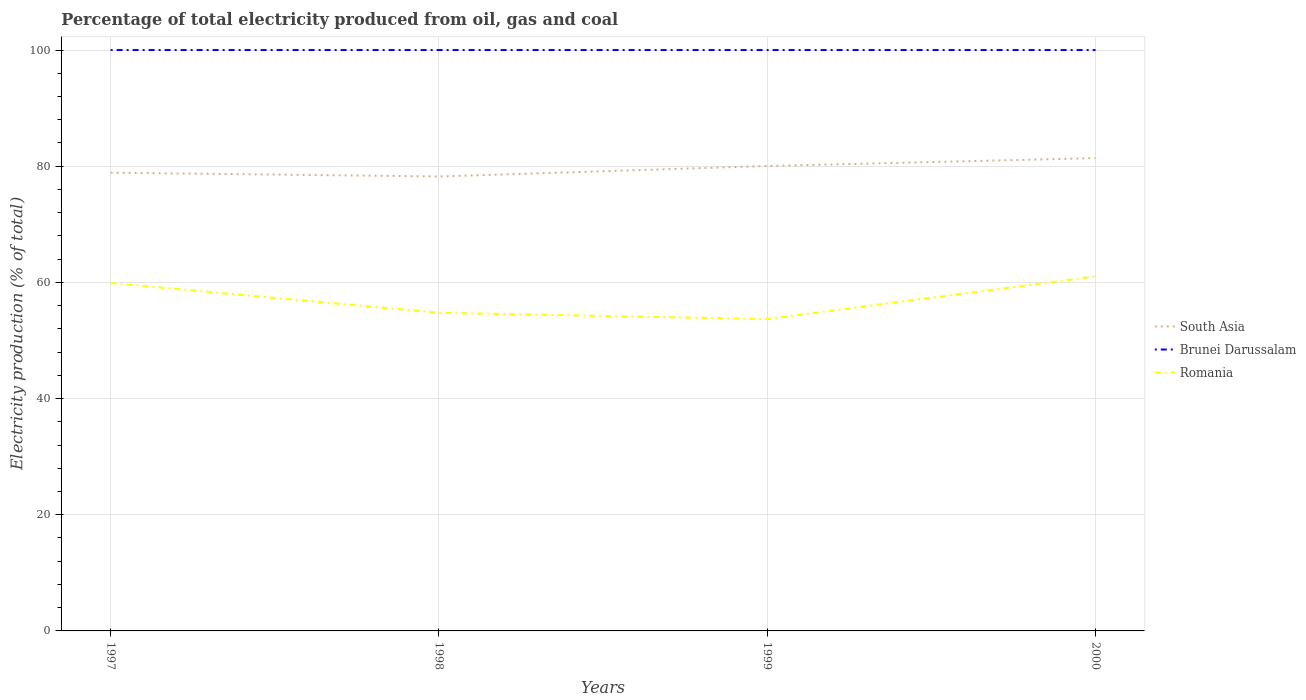Does the line corresponding to Romania intersect with the line corresponding to Brunei Darussalam?
Your answer should be very brief. No. Is the number of lines equal to the number of legend labels?
Provide a succinct answer. Yes. What is the total electricity production in in Brunei Darussalam in the graph?
Give a very brief answer. 0. What is the difference between the highest and the second highest electricity production in in Romania?
Offer a very short reply. 7.36. What is the difference between the highest and the lowest electricity production in in South Asia?
Provide a succinct answer. 2. Is the electricity production in in Romania strictly greater than the electricity production in in Brunei Darussalam over the years?
Keep it short and to the point. Yes. What is the difference between two consecutive major ticks on the Y-axis?
Provide a succinct answer. 20. Does the graph contain any zero values?
Keep it short and to the point. No. How many legend labels are there?
Ensure brevity in your answer.  3. What is the title of the graph?
Make the answer very short. Percentage of total electricity produced from oil, gas and coal. Does "American Samoa" appear as one of the legend labels in the graph?
Keep it short and to the point. No. What is the label or title of the Y-axis?
Offer a very short reply. Electricity production (% of total). What is the Electricity production (% of total) of South Asia in 1997?
Your answer should be very brief. 78.88. What is the Electricity production (% of total) in Romania in 1997?
Offer a very short reply. 59.89. What is the Electricity production (% of total) in South Asia in 1998?
Ensure brevity in your answer.  78.23. What is the Electricity production (% of total) of Romania in 1998?
Ensure brevity in your answer.  54.77. What is the Electricity production (% of total) in South Asia in 1999?
Provide a short and direct response. 80.04. What is the Electricity production (% of total) in Brunei Darussalam in 1999?
Give a very brief answer. 100. What is the Electricity production (% of total) in Romania in 1999?
Offer a terse response. 53.68. What is the Electricity production (% of total) of South Asia in 2000?
Ensure brevity in your answer.  81.39. What is the Electricity production (% of total) in Romania in 2000?
Provide a short and direct response. 61.04. Across all years, what is the maximum Electricity production (% of total) of South Asia?
Provide a short and direct response. 81.39. Across all years, what is the maximum Electricity production (% of total) in Romania?
Your response must be concise. 61.04. Across all years, what is the minimum Electricity production (% of total) of South Asia?
Ensure brevity in your answer.  78.23. Across all years, what is the minimum Electricity production (% of total) in Romania?
Keep it short and to the point. 53.68. What is the total Electricity production (% of total) of South Asia in the graph?
Your answer should be compact. 318.55. What is the total Electricity production (% of total) of Brunei Darussalam in the graph?
Provide a short and direct response. 400. What is the total Electricity production (% of total) in Romania in the graph?
Offer a terse response. 229.38. What is the difference between the Electricity production (% of total) of South Asia in 1997 and that in 1998?
Ensure brevity in your answer.  0.65. What is the difference between the Electricity production (% of total) of Brunei Darussalam in 1997 and that in 1998?
Give a very brief answer. 0. What is the difference between the Electricity production (% of total) of Romania in 1997 and that in 1998?
Provide a short and direct response. 5.12. What is the difference between the Electricity production (% of total) in South Asia in 1997 and that in 1999?
Your answer should be very brief. -1.15. What is the difference between the Electricity production (% of total) of Romania in 1997 and that in 1999?
Your answer should be very brief. 6.21. What is the difference between the Electricity production (% of total) in South Asia in 1997 and that in 2000?
Keep it short and to the point. -2.51. What is the difference between the Electricity production (% of total) in Romania in 1997 and that in 2000?
Keep it short and to the point. -1.15. What is the difference between the Electricity production (% of total) in South Asia in 1998 and that in 1999?
Offer a very short reply. -1.81. What is the difference between the Electricity production (% of total) in Romania in 1998 and that in 1999?
Provide a short and direct response. 1.09. What is the difference between the Electricity production (% of total) in South Asia in 1998 and that in 2000?
Your answer should be very brief. -3.16. What is the difference between the Electricity production (% of total) of Brunei Darussalam in 1998 and that in 2000?
Your answer should be very brief. 0. What is the difference between the Electricity production (% of total) in Romania in 1998 and that in 2000?
Keep it short and to the point. -6.27. What is the difference between the Electricity production (% of total) of South Asia in 1999 and that in 2000?
Give a very brief answer. -1.36. What is the difference between the Electricity production (% of total) in Brunei Darussalam in 1999 and that in 2000?
Provide a short and direct response. 0. What is the difference between the Electricity production (% of total) in Romania in 1999 and that in 2000?
Offer a terse response. -7.36. What is the difference between the Electricity production (% of total) of South Asia in 1997 and the Electricity production (% of total) of Brunei Darussalam in 1998?
Provide a succinct answer. -21.12. What is the difference between the Electricity production (% of total) in South Asia in 1997 and the Electricity production (% of total) in Romania in 1998?
Your answer should be compact. 24.11. What is the difference between the Electricity production (% of total) in Brunei Darussalam in 1997 and the Electricity production (% of total) in Romania in 1998?
Keep it short and to the point. 45.23. What is the difference between the Electricity production (% of total) of South Asia in 1997 and the Electricity production (% of total) of Brunei Darussalam in 1999?
Keep it short and to the point. -21.12. What is the difference between the Electricity production (% of total) of South Asia in 1997 and the Electricity production (% of total) of Romania in 1999?
Your answer should be compact. 25.2. What is the difference between the Electricity production (% of total) in Brunei Darussalam in 1997 and the Electricity production (% of total) in Romania in 1999?
Give a very brief answer. 46.32. What is the difference between the Electricity production (% of total) of South Asia in 1997 and the Electricity production (% of total) of Brunei Darussalam in 2000?
Offer a terse response. -21.12. What is the difference between the Electricity production (% of total) of South Asia in 1997 and the Electricity production (% of total) of Romania in 2000?
Keep it short and to the point. 17.84. What is the difference between the Electricity production (% of total) of Brunei Darussalam in 1997 and the Electricity production (% of total) of Romania in 2000?
Offer a very short reply. 38.96. What is the difference between the Electricity production (% of total) of South Asia in 1998 and the Electricity production (% of total) of Brunei Darussalam in 1999?
Give a very brief answer. -21.77. What is the difference between the Electricity production (% of total) in South Asia in 1998 and the Electricity production (% of total) in Romania in 1999?
Provide a succinct answer. 24.55. What is the difference between the Electricity production (% of total) in Brunei Darussalam in 1998 and the Electricity production (% of total) in Romania in 1999?
Provide a short and direct response. 46.32. What is the difference between the Electricity production (% of total) in South Asia in 1998 and the Electricity production (% of total) in Brunei Darussalam in 2000?
Make the answer very short. -21.77. What is the difference between the Electricity production (% of total) in South Asia in 1998 and the Electricity production (% of total) in Romania in 2000?
Provide a short and direct response. 17.19. What is the difference between the Electricity production (% of total) in Brunei Darussalam in 1998 and the Electricity production (% of total) in Romania in 2000?
Provide a short and direct response. 38.96. What is the difference between the Electricity production (% of total) in South Asia in 1999 and the Electricity production (% of total) in Brunei Darussalam in 2000?
Your answer should be very brief. -19.96. What is the difference between the Electricity production (% of total) of South Asia in 1999 and the Electricity production (% of total) of Romania in 2000?
Your answer should be compact. 19. What is the difference between the Electricity production (% of total) in Brunei Darussalam in 1999 and the Electricity production (% of total) in Romania in 2000?
Your response must be concise. 38.96. What is the average Electricity production (% of total) in South Asia per year?
Your answer should be compact. 79.64. What is the average Electricity production (% of total) of Brunei Darussalam per year?
Your answer should be compact. 100. What is the average Electricity production (% of total) of Romania per year?
Offer a terse response. 57.35. In the year 1997, what is the difference between the Electricity production (% of total) of South Asia and Electricity production (% of total) of Brunei Darussalam?
Offer a very short reply. -21.12. In the year 1997, what is the difference between the Electricity production (% of total) in South Asia and Electricity production (% of total) in Romania?
Keep it short and to the point. 18.99. In the year 1997, what is the difference between the Electricity production (% of total) of Brunei Darussalam and Electricity production (% of total) of Romania?
Offer a very short reply. 40.11. In the year 1998, what is the difference between the Electricity production (% of total) of South Asia and Electricity production (% of total) of Brunei Darussalam?
Keep it short and to the point. -21.77. In the year 1998, what is the difference between the Electricity production (% of total) in South Asia and Electricity production (% of total) in Romania?
Provide a short and direct response. 23.46. In the year 1998, what is the difference between the Electricity production (% of total) in Brunei Darussalam and Electricity production (% of total) in Romania?
Your answer should be compact. 45.23. In the year 1999, what is the difference between the Electricity production (% of total) in South Asia and Electricity production (% of total) in Brunei Darussalam?
Your answer should be compact. -19.96. In the year 1999, what is the difference between the Electricity production (% of total) of South Asia and Electricity production (% of total) of Romania?
Your answer should be very brief. 26.36. In the year 1999, what is the difference between the Electricity production (% of total) in Brunei Darussalam and Electricity production (% of total) in Romania?
Make the answer very short. 46.32. In the year 2000, what is the difference between the Electricity production (% of total) of South Asia and Electricity production (% of total) of Brunei Darussalam?
Make the answer very short. -18.61. In the year 2000, what is the difference between the Electricity production (% of total) of South Asia and Electricity production (% of total) of Romania?
Provide a short and direct response. 20.35. In the year 2000, what is the difference between the Electricity production (% of total) of Brunei Darussalam and Electricity production (% of total) of Romania?
Offer a terse response. 38.96. What is the ratio of the Electricity production (% of total) of South Asia in 1997 to that in 1998?
Your answer should be very brief. 1.01. What is the ratio of the Electricity production (% of total) of Romania in 1997 to that in 1998?
Make the answer very short. 1.09. What is the ratio of the Electricity production (% of total) in South Asia in 1997 to that in 1999?
Your answer should be very brief. 0.99. What is the ratio of the Electricity production (% of total) of Romania in 1997 to that in 1999?
Offer a very short reply. 1.12. What is the ratio of the Electricity production (% of total) in South Asia in 1997 to that in 2000?
Make the answer very short. 0.97. What is the ratio of the Electricity production (% of total) of Romania in 1997 to that in 2000?
Offer a terse response. 0.98. What is the ratio of the Electricity production (% of total) of South Asia in 1998 to that in 1999?
Provide a succinct answer. 0.98. What is the ratio of the Electricity production (% of total) in Brunei Darussalam in 1998 to that in 1999?
Provide a short and direct response. 1. What is the ratio of the Electricity production (% of total) in Romania in 1998 to that in 1999?
Offer a terse response. 1.02. What is the ratio of the Electricity production (% of total) in South Asia in 1998 to that in 2000?
Keep it short and to the point. 0.96. What is the ratio of the Electricity production (% of total) of Romania in 1998 to that in 2000?
Offer a very short reply. 0.9. What is the ratio of the Electricity production (% of total) in South Asia in 1999 to that in 2000?
Give a very brief answer. 0.98. What is the ratio of the Electricity production (% of total) of Brunei Darussalam in 1999 to that in 2000?
Provide a short and direct response. 1. What is the ratio of the Electricity production (% of total) in Romania in 1999 to that in 2000?
Provide a short and direct response. 0.88. What is the difference between the highest and the second highest Electricity production (% of total) in South Asia?
Give a very brief answer. 1.36. What is the difference between the highest and the second highest Electricity production (% of total) in Brunei Darussalam?
Provide a short and direct response. 0. What is the difference between the highest and the second highest Electricity production (% of total) in Romania?
Your response must be concise. 1.15. What is the difference between the highest and the lowest Electricity production (% of total) in South Asia?
Your answer should be compact. 3.16. What is the difference between the highest and the lowest Electricity production (% of total) of Brunei Darussalam?
Your answer should be very brief. 0. What is the difference between the highest and the lowest Electricity production (% of total) in Romania?
Offer a terse response. 7.36. 